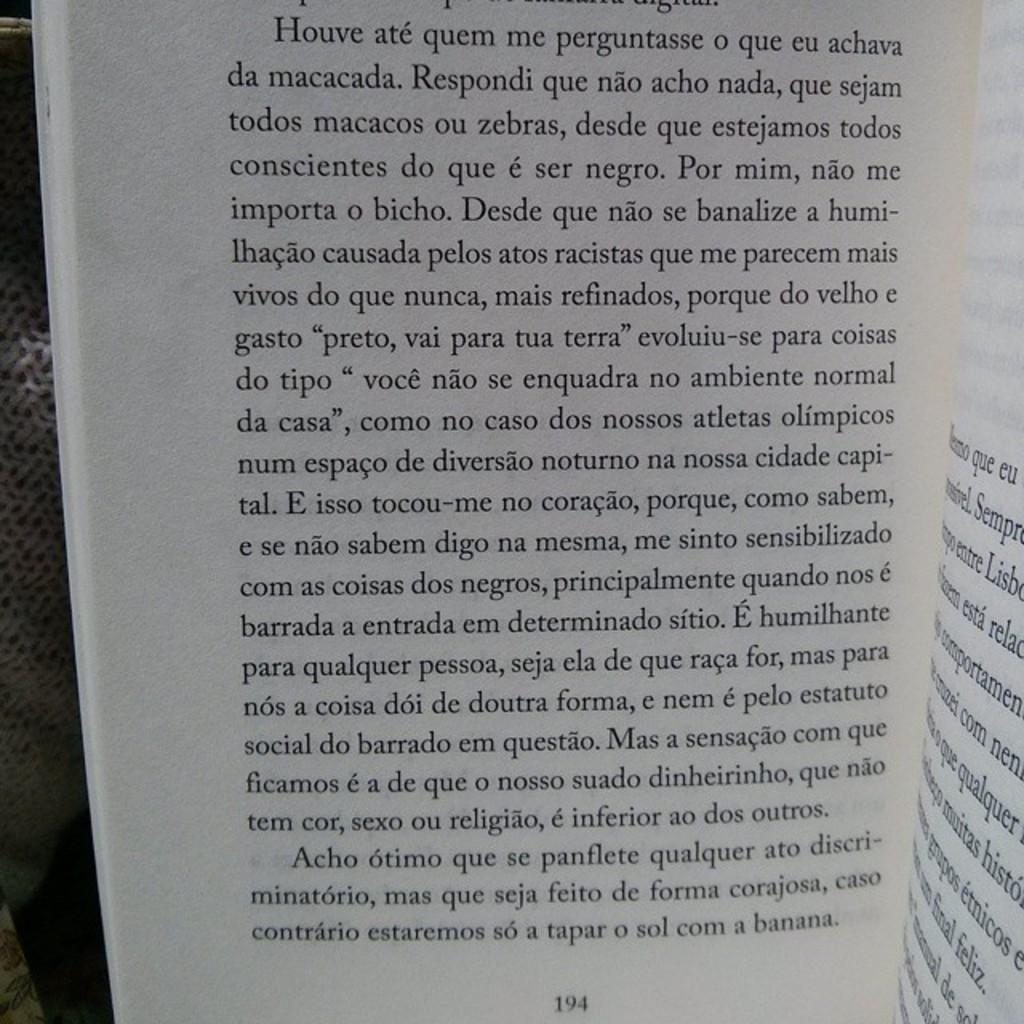<image>
Render a clear and concise summary of the photo. An open book that is on page 194. 